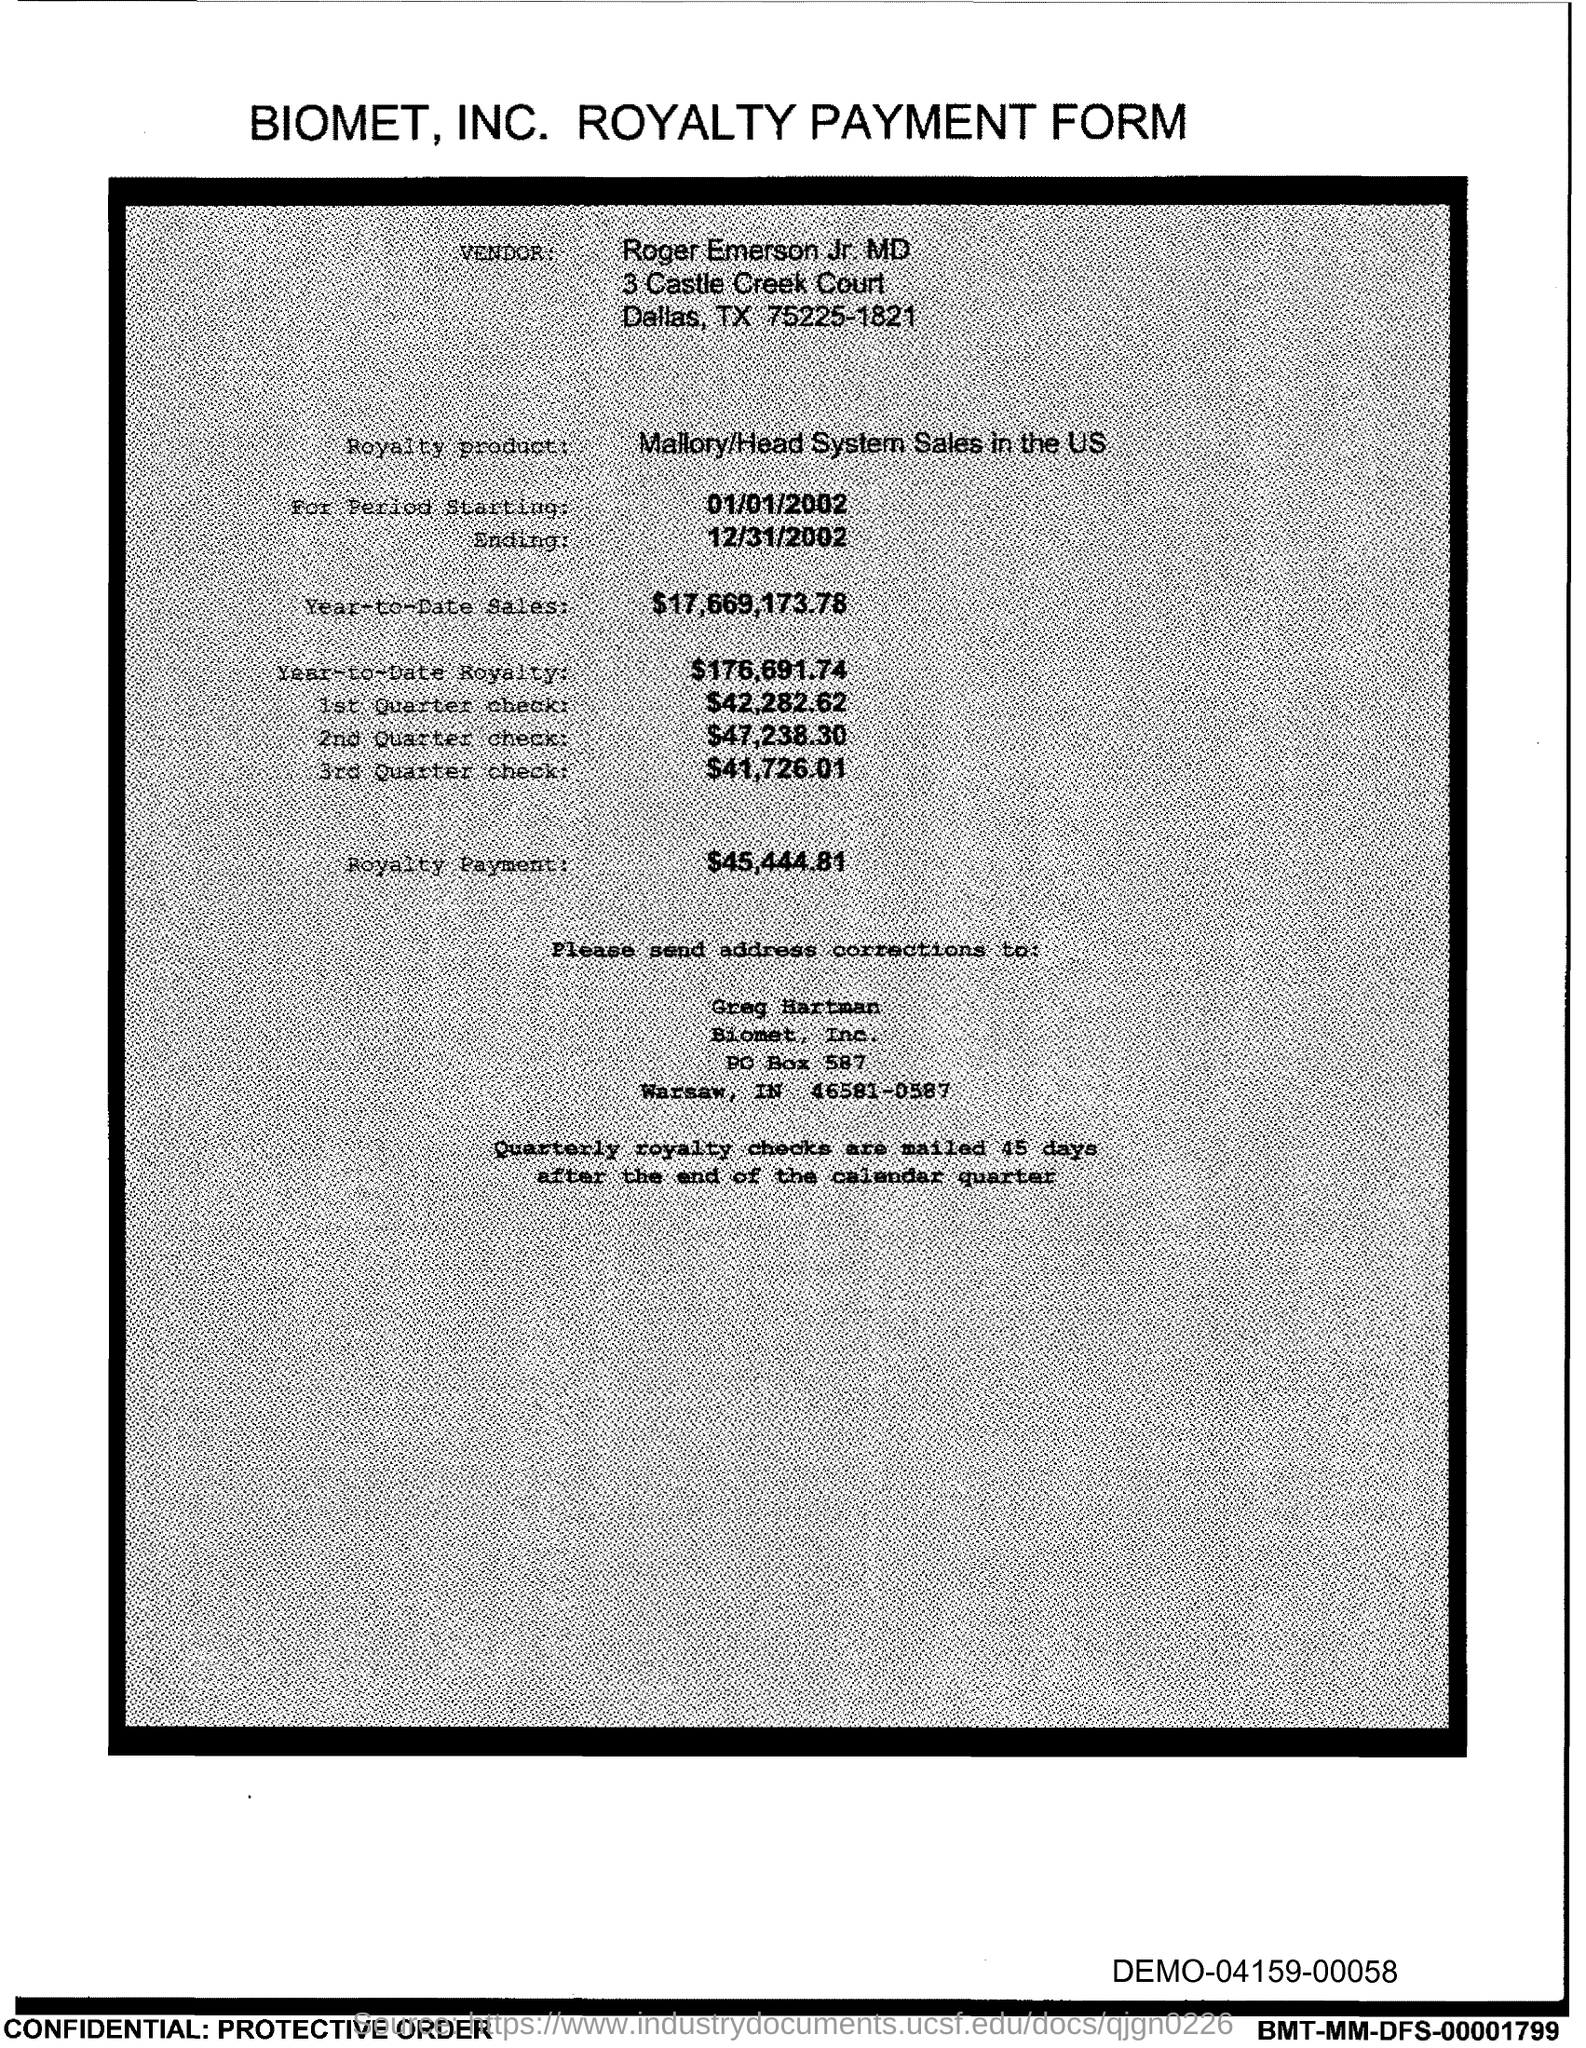Highlight a few significant elements in this photo. The first quarter check amount is $42,282.62. The starting period mentioned is 01/01/2002. The person to whom address corrections are sent is Greg Hartman. The ending period mentioned is 12/31/2002. The royalty payment is $45,444.81. 